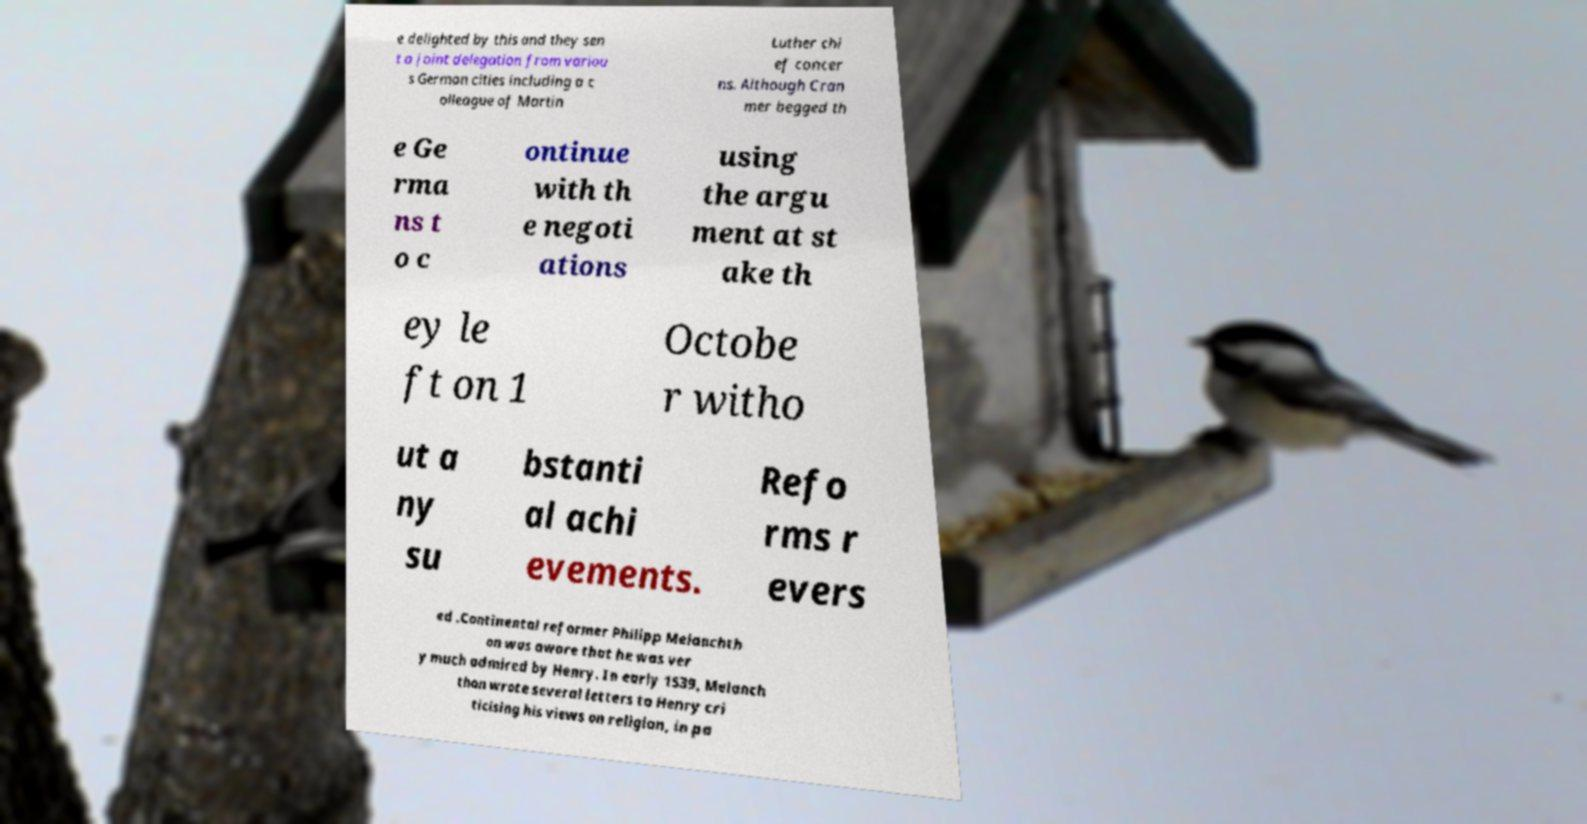There's text embedded in this image that I need extracted. Can you transcribe it verbatim? e delighted by this and they sen t a joint delegation from variou s German cities including a c olleague of Martin Luther chi ef concer ns. Although Cran mer begged th e Ge rma ns t o c ontinue with th e negoti ations using the argu ment at st ake th ey le ft on 1 Octobe r witho ut a ny su bstanti al achi evements. Refo rms r evers ed .Continental reformer Philipp Melanchth on was aware that he was ver y much admired by Henry. In early 1539, Melanch thon wrote several letters to Henry cri ticising his views on religion, in pa 